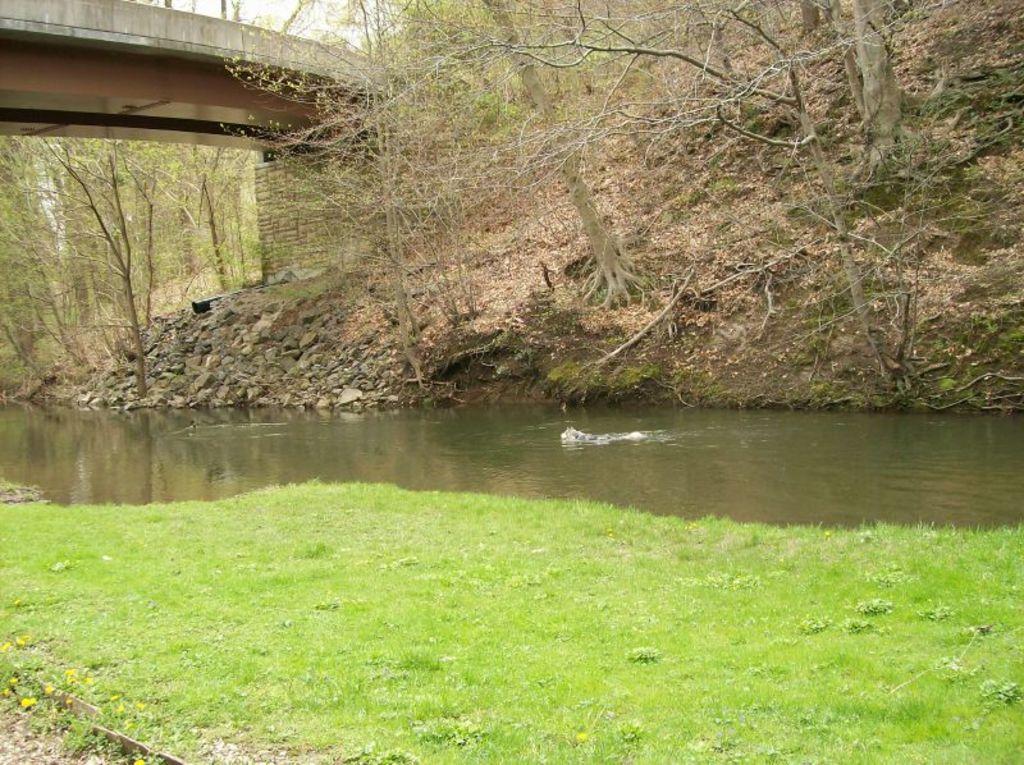In one or two sentences, can you explain what this image depicts? Front portion of the image we can see grass and water. Background portion of the image there are trees, rocks, wall and bridge. 